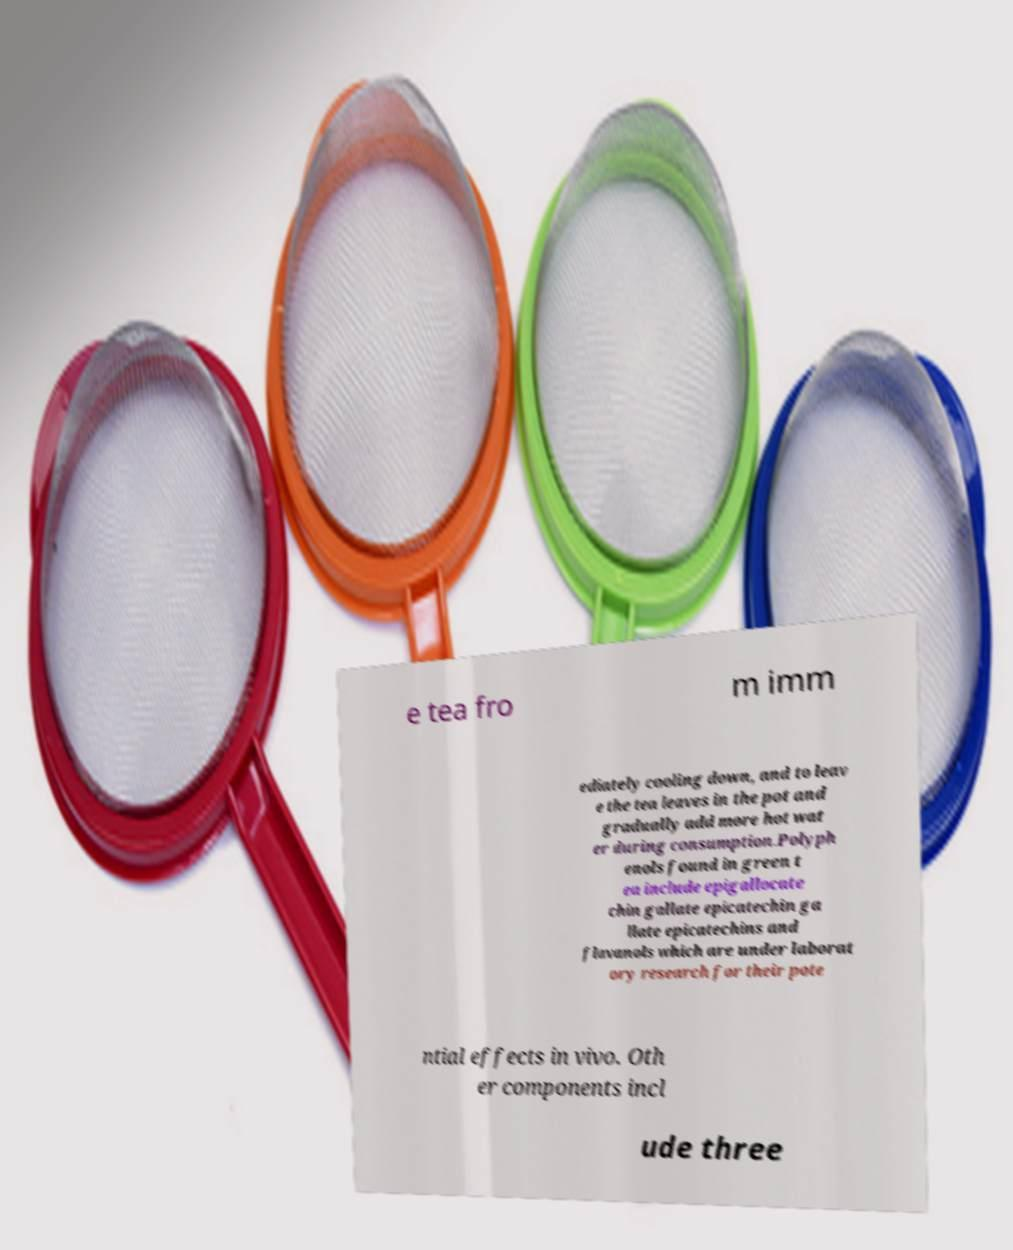For documentation purposes, I need the text within this image transcribed. Could you provide that? e tea fro m imm ediately cooling down, and to leav e the tea leaves in the pot and gradually add more hot wat er during consumption.Polyph enols found in green t ea include epigallocate chin gallate epicatechin ga llate epicatechins and flavanols which are under laborat ory research for their pote ntial effects in vivo. Oth er components incl ude three 